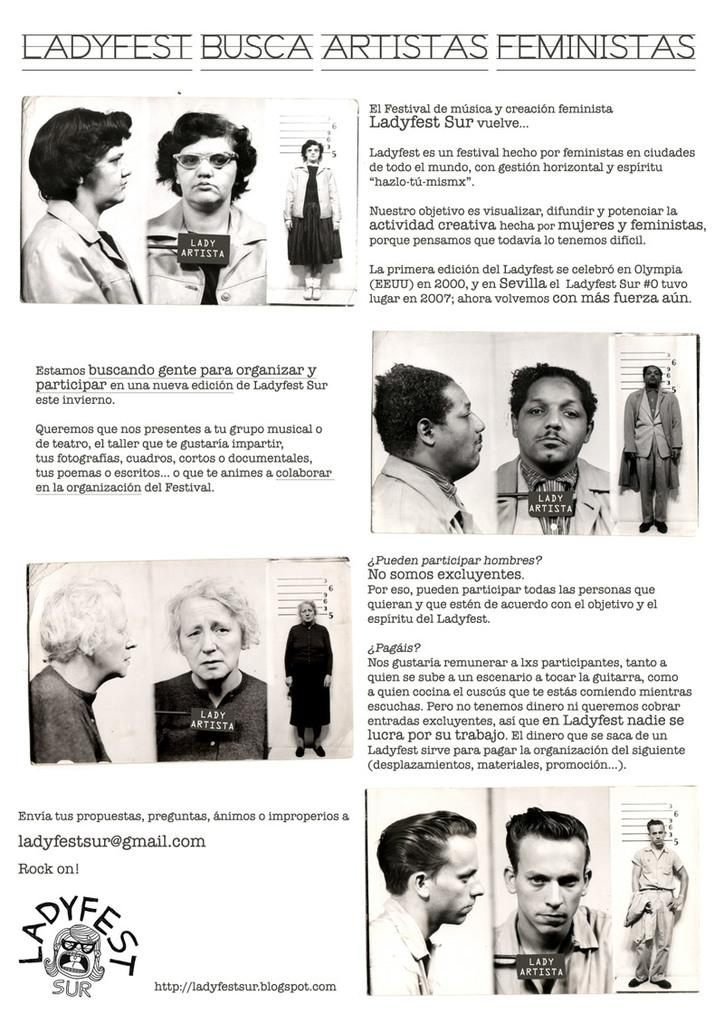What is present in the picture? There is a poster in the picture. What can be seen on the poster? The poster contains images of persons. Are there any words on the poster? Yes, there are words on the poster. What is the opinion of the person in the poster about the copy of the amusement park? There is no information about the person's opinion or an amusement park in the image. 